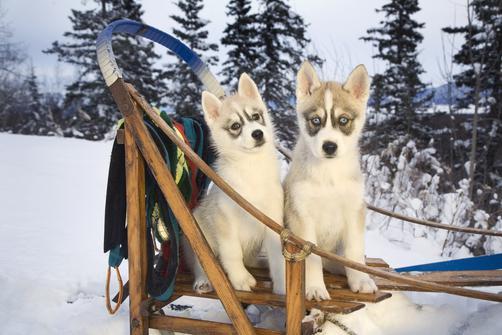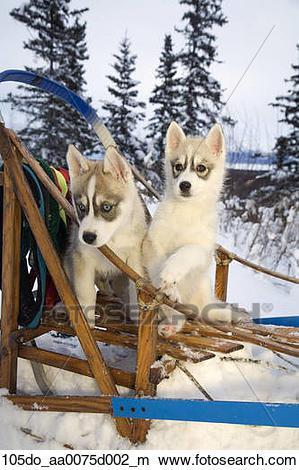The first image is the image on the left, the second image is the image on the right. Assess this claim about the two images: "Each image shows at least one dog in a sled, and one image features at least three young puppies in a sled with something red behind them.". Correct or not? Answer yes or no. No. The first image is the image on the left, the second image is the image on the right. Given the left and right images, does the statement "Two dogs sit on a wooden structure in the image on the left." hold true? Answer yes or no. Yes. 